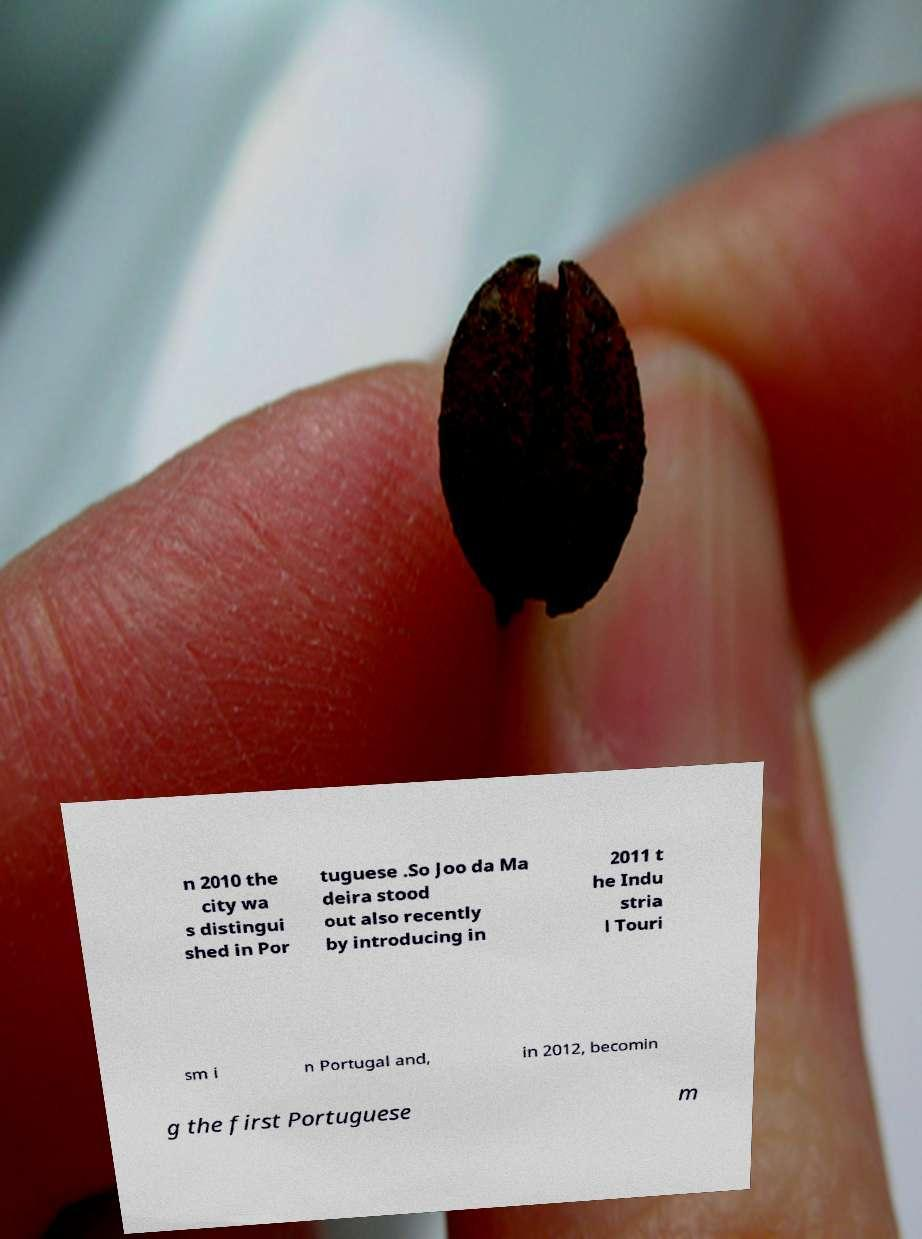Please read and relay the text visible in this image. What does it say? n 2010 the city wa s distingui shed in Por tuguese .So Joo da Ma deira stood out also recently by introducing in 2011 t he Indu stria l Touri sm i n Portugal and, in 2012, becomin g the first Portuguese m 